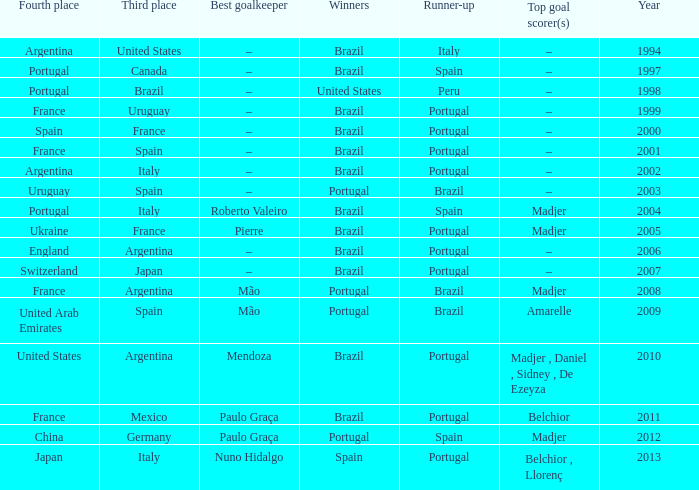Who were the winners in 1998? United States. Could you parse the entire table? {'header': ['Fourth place', 'Third place', 'Best goalkeeper', 'Winners', 'Runner-up', 'Top goal scorer(s)', 'Year'], 'rows': [['Argentina', 'United States', '–', 'Brazil', 'Italy', '–', '1994'], ['Portugal', 'Canada', '–', 'Brazil', 'Spain', '–', '1997'], ['Portugal', 'Brazil', '–', 'United States', 'Peru', '–', '1998'], ['France', 'Uruguay', '–', 'Brazil', 'Portugal', '–', '1999'], ['Spain', 'France', '–', 'Brazil', 'Portugal', '–', '2000'], ['France', 'Spain', '–', 'Brazil', 'Portugal', '–', '2001'], ['Argentina', 'Italy', '–', 'Brazil', 'Portugal', '–', '2002'], ['Uruguay', 'Spain', '–', 'Portugal', 'Brazil', '–', '2003'], ['Portugal', 'Italy', 'Roberto Valeiro', 'Brazil', 'Spain', 'Madjer', '2004'], ['Ukraine', 'France', 'Pierre', 'Brazil', 'Portugal', 'Madjer', '2005'], ['England', 'Argentina', '–', 'Brazil', 'Portugal', '–', '2006'], ['Switzerland', 'Japan', '–', 'Brazil', 'Portugal', '–', '2007'], ['France', 'Argentina', 'Mão', 'Portugal', 'Brazil', 'Madjer', '2008'], ['United Arab Emirates', 'Spain', 'Mão', 'Portugal', 'Brazil', 'Amarelle', '2009'], ['United States', 'Argentina', 'Mendoza', 'Brazil', 'Portugal', 'Madjer , Daniel , Sidney , De Ezeyza', '2010'], ['France', 'Mexico', 'Paulo Graça', 'Brazil', 'Portugal', 'Belchior', '2011'], ['China', 'Germany', 'Paulo Graça', 'Portugal', 'Spain', 'Madjer', '2012'], ['Japan', 'Italy', 'Nuno Hidalgo', 'Spain', 'Portugal', 'Belchior , Llorenç', '2013']]} 